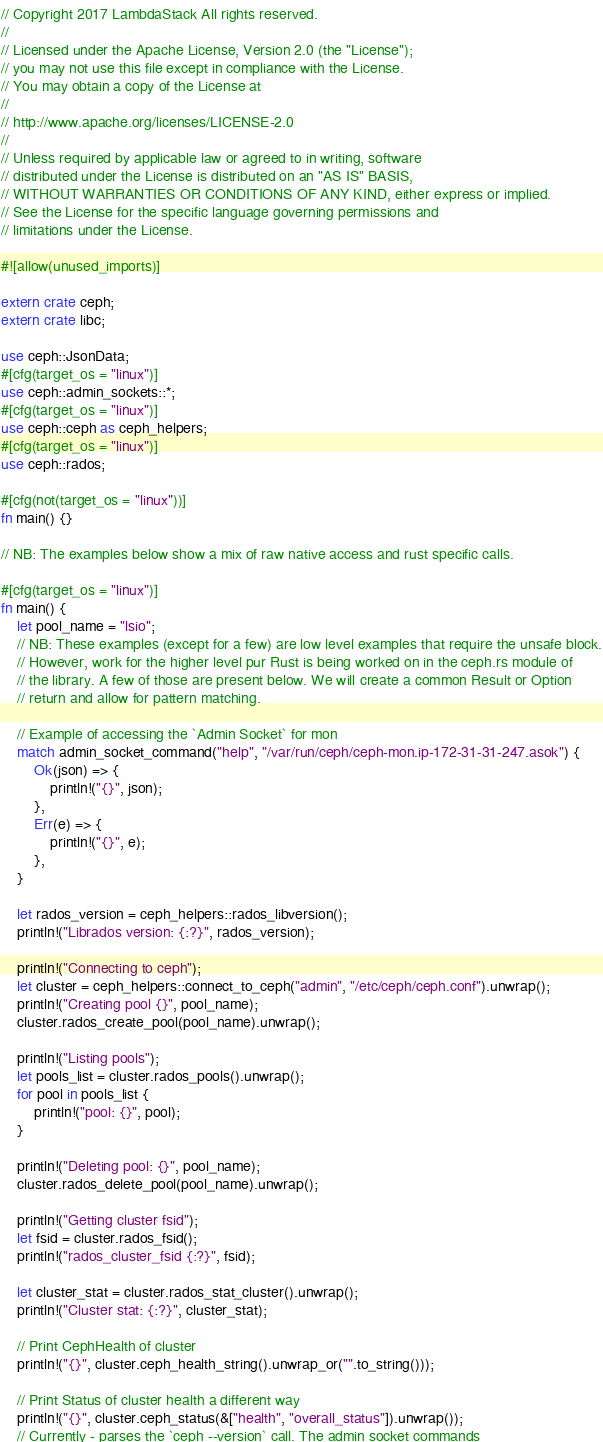<code> <loc_0><loc_0><loc_500><loc_500><_Rust_>// Copyright 2017 LambdaStack All rights reserved.
//
// Licensed under the Apache License, Version 2.0 (the "License");
// you may not use this file except in compliance with the License.
// You may obtain a copy of the License at
//
// http://www.apache.org/licenses/LICENSE-2.0
//
// Unless required by applicable law or agreed to in writing, software
// distributed under the License is distributed on an "AS IS" BASIS,
// WITHOUT WARRANTIES OR CONDITIONS OF ANY KIND, either express or implied.
// See the License for the specific language governing permissions and
// limitations under the License.

#![allow(unused_imports)]

extern crate ceph;
extern crate libc;

use ceph::JsonData;
#[cfg(target_os = "linux")]
use ceph::admin_sockets::*;
#[cfg(target_os = "linux")]
use ceph::ceph as ceph_helpers;
#[cfg(target_os = "linux")]
use ceph::rados;

#[cfg(not(target_os = "linux"))]
fn main() {}

// NB: The examples below show a mix of raw native access and rust specific calls.

#[cfg(target_os = "linux")]
fn main() {
    let pool_name = "lsio";
    // NB: These examples (except for a few) are low level examples that require the unsafe block.
    // However, work for the higher level pur Rust is being worked on in the ceph.rs module of
    // the library. A few of those are present below. We will create a common Result or Option
    // return and allow for pattern matching.

    // Example of accessing the `Admin Socket` for mon
    match admin_socket_command("help", "/var/run/ceph/ceph-mon.ip-172-31-31-247.asok") {
        Ok(json) => {
            println!("{}", json);
        },
        Err(e) => {
            println!("{}", e);
        },
    }

    let rados_version = ceph_helpers::rados_libversion();
    println!("Librados version: {:?}", rados_version);

    println!("Connecting to ceph");
    let cluster = ceph_helpers::connect_to_ceph("admin", "/etc/ceph/ceph.conf").unwrap();
    println!("Creating pool {}", pool_name);
    cluster.rados_create_pool(pool_name).unwrap();

    println!("Listing pools");
    let pools_list = cluster.rados_pools().unwrap();
    for pool in pools_list {
        println!("pool: {}", pool);
    }

    println!("Deleting pool: {}", pool_name);
    cluster.rados_delete_pool(pool_name).unwrap();

    println!("Getting cluster fsid");
    let fsid = cluster.rados_fsid();
    println!("rados_cluster_fsid {:?}", fsid);

    let cluster_stat = cluster.rados_stat_cluster().unwrap();
    println!("Cluster stat: {:?}", cluster_stat);

    // Print CephHealth of cluster
    println!("{}", cluster.ceph_health_string().unwrap_or("".to_string()));

    // Print Status of cluster health a different way
    println!("{}", cluster.ceph_status(&["health", "overall_status"]).unwrap());
    // Currently - parses the `ceph --version` call. The admin socket commands</code> 